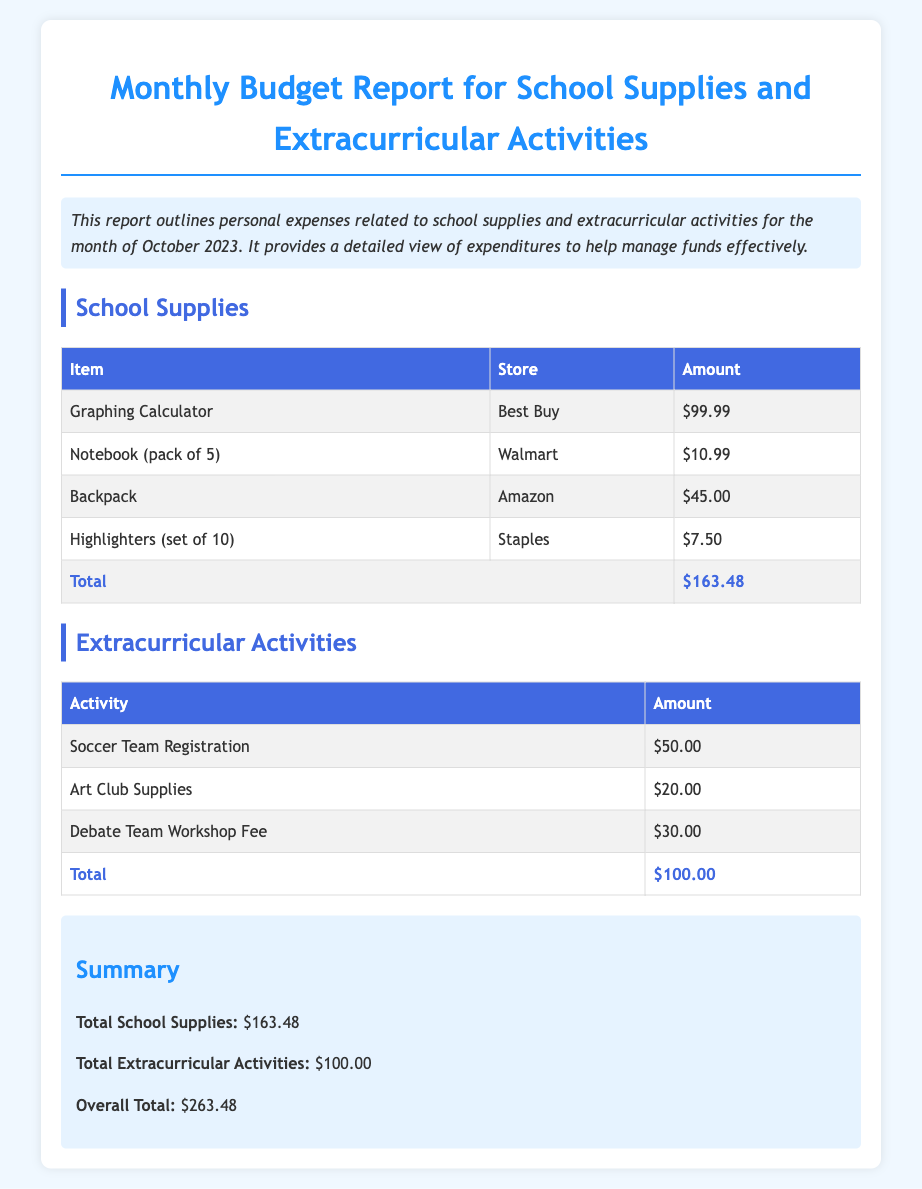What is the total amount spent on school supplies? The total amount spent on school supplies is listed in the table under the "Total" row.
Answer: $163.48 How much was spent on the debate team workshop fee? The amount spent on the debate team workshop fee is found in the extracurricular activities table.
Answer: $30.00 What store was the graphing calculator purchased from? The store where the graphing calculator was purchased is listed in the school supplies table next to the item.
Answer: Best Buy What is the overall total of all expenses? The overall total is indicated in the summary section, combining both school supplies and extracurricular activities expenses.
Answer: $263.48 How much was spent on art club supplies? The amount for art club supplies can be found in the extracurricular activities table.
Answer: $20.00 What is the most expensive school supply item listed? The most expensive item is determined by comparing the amounts in the school supplies table.
Answer: Graphing Calculator Which two types of expenses are categorized in the report? The two types of expenses are explicitly mentioned in the introduction of the report.
Answer: School Supplies and Extracurricular Activities What color is the background of the report? The background color of the report is specified in the CSS styles for the body.
Answer: Light Blue 